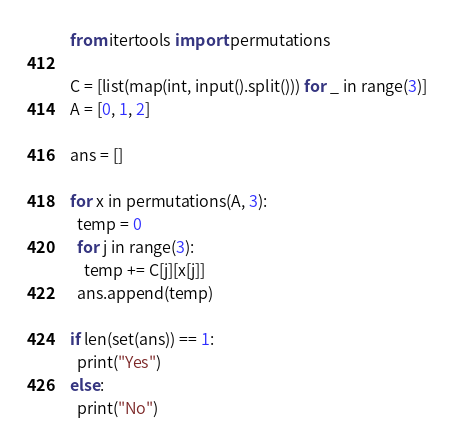Convert code to text. <code><loc_0><loc_0><loc_500><loc_500><_Python_>from itertools import permutations

C = [list(map(int, input().split())) for _ in range(3)]
A = [0, 1, 2]

ans = []

for x in permutations(A, 3):
  temp = 0
  for j in range(3):
    temp += C[j][x[j]]
  ans.append(temp)
    
if len(set(ans)) == 1:
  print("Yes")
else:
  print("No")</code> 